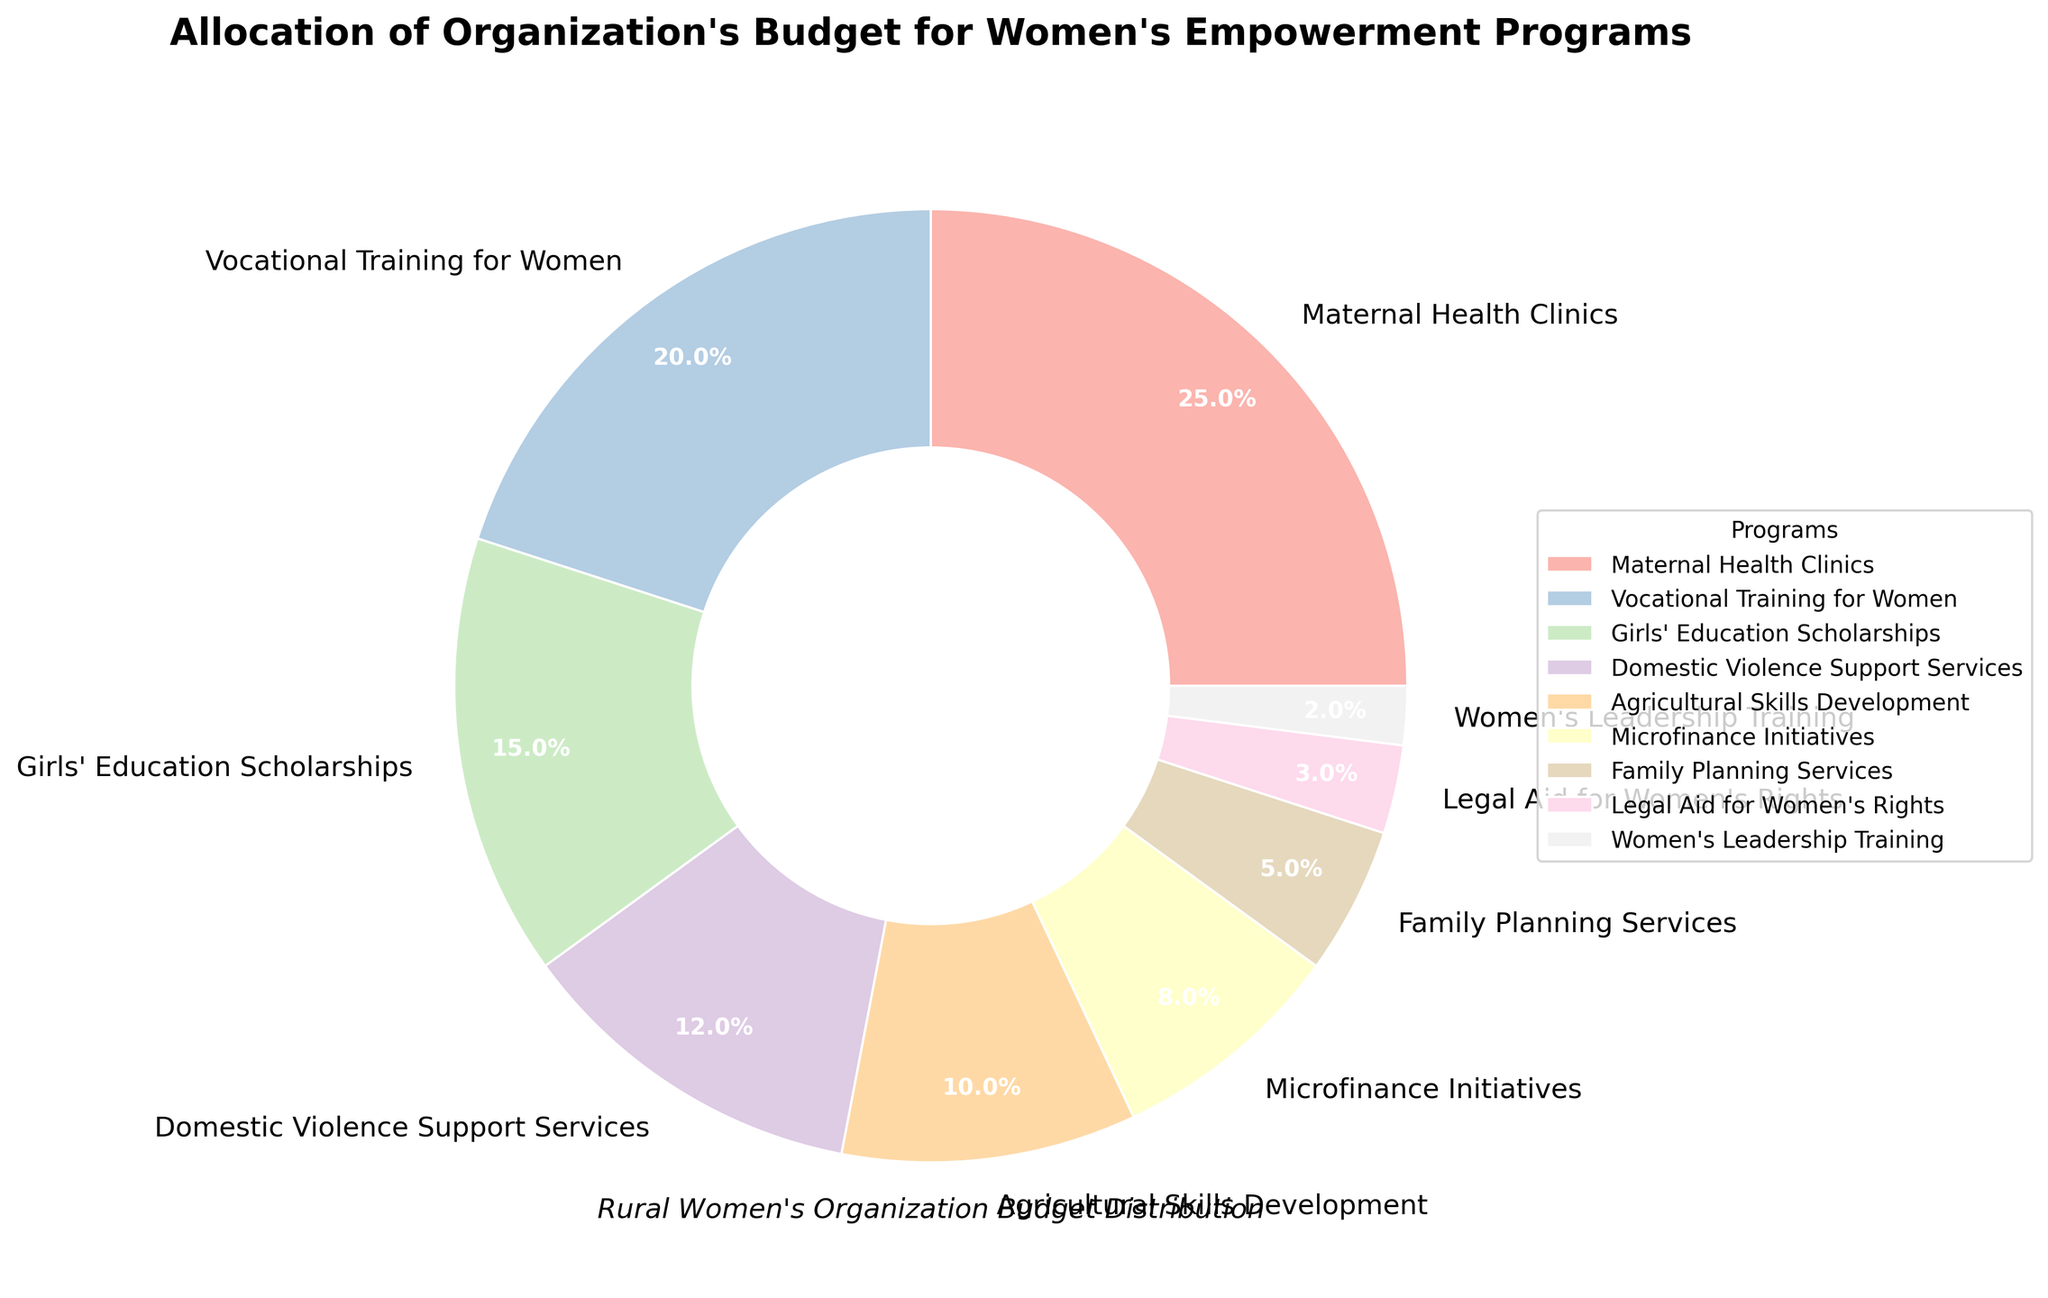What is the largest budget allocation in the figure? The largest budget allocation is indicated by the largest wedge in the pie chart, which is labeled "Maternal Health Clinics." The percentage shown on the wedge is 25%.
Answer: 25% What is the combined budget allocation for "Vocational Training for Women" and "Girls' Education Scholarships"? To find the combined budget allocation, add the percentages of "Vocational Training for Women" (20%) and "Girls' Education Scholarships" (15%). 20% + 15% = 35%.
Answer: 35% Which program has a larger budget allocation: "Family Planning Services" or "Microfinance Initiatives"? Compare the percentages of "Family Planning Services" (5%) and "Microfinance Initiatives" (8%). The wedge for "Microfinance Initiatives" is larger, indicating a higher allocation.
Answer: Microfinance Initiatives What is the difference in budget allocation between "Domestic Violence Support Services" and "Agricultural Skills Development"? Subtract the allocation percentage of "Agricultural Skills Development" (10%) from "Domestic Violence Support Services" (12%). 12% - 10% = 2%.
Answer: 2% Which program has the smallest budget allocation? The smallest wedge in the pie chart represents "Women's Leadership Training," with a percentage of 2%.
Answer: Women's Leadership Training Is the total budget allocation for "Maternal Health Clinics" and "Legal Aid for Women's Rights" greater than 27%? Add the percentages for "Maternal Health Clinics" (25%) and "Legal Aid for Women's Rights" (3%). 25% + 3% = 28%, which is more than 27%.
Answer: Yes How many programs have a budget allocation greater than or equal to 10%? Identify programs with allocations of 10% or more: "Maternal Health Clinics" (25%), "Vocational Training for Women" (20%), "Girls' Education Scholarships" (15%), and "Domestic Violence Support Services" (12%), "Agricultural Skills Development" (10%). Count them: 5 programs.
Answer: 5 What is the total percentage allocated to programs related to health (Maternal Health Clinics, Family Planning Services)? Add the percentages for "Maternal Health Clinics" (25%) and "Family Planning Services" (5%). 25% + 5% = 30%.
Answer: 30% What is the average budget allocation for the programs listed in the figure? To calculate the average, sum all the percentages and divide by the number of programs. (25 + 20 + 15 + 12 + 10 + 8 + 5 + 3 + 2) / 9 = 11.11%.
Answer: 11.11% Which programs together make up exactly one-third (33.33%) of the total budget allocation? By adding percentages systematically, "Vocational Training for Women" (20%) and "Agricultural Skills Development" (10%) together make 30%, which is closest under one-third. Adding "Women's Leadership Training" (2%) brings it to 32%. Adding "Legal Aid for Women's Rights" (3%) totals to 35%, which exceeds one-third. The exact combination isn’t found among these individual add-ups.
Answer: (No exact match) 